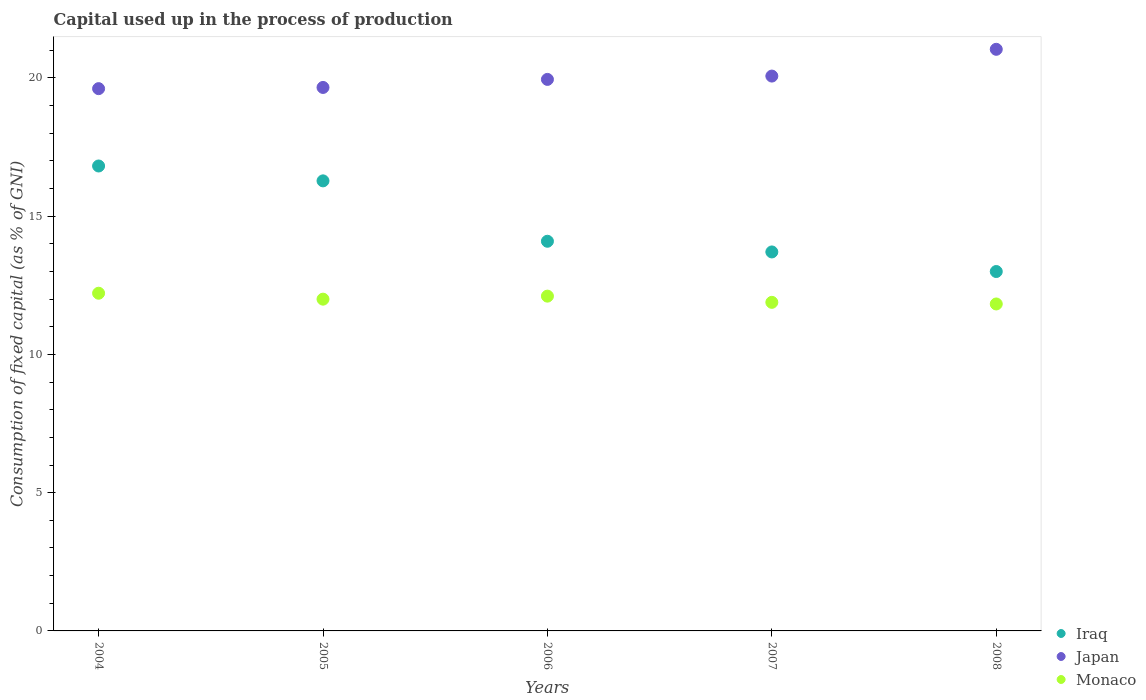How many different coloured dotlines are there?
Ensure brevity in your answer.  3. What is the capital used up in the process of production in Iraq in 2005?
Ensure brevity in your answer.  16.28. Across all years, what is the maximum capital used up in the process of production in Iraq?
Provide a short and direct response. 16.81. Across all years, what is the minimum capital used up in the process of production in Iraq?
Provide a short and direct response. 13. In which year was the capital used up in the process of production in Japan maximum?
Keep it short and to the point. 2008. In which year was the capital used up in the process of production in Iraq minimum?
Ensure brevity in your answer.  2008. What is the total capital used up in the process of production in Iraq in the graph?
Ensure brevity in your answer.  73.88. What is the difference between the capital used up in the process of production in Japan in 2007 and that in 2008?
Your answer should be compact. -0.97. What is the difference between the capital used up in the process of production in Iraq in 2005 and the capital used up in the process of production in Japan in 2007?
Your response must be concise. -3.79. What is the average capital used up in the process of production in Monaco per year?
Your answer should be very brief. 12. In the year 2007, what is the difference between the capital used up in the process of production in Iraq and capital used up in the process of production in Monaco?
Keep it short and to the point. 1.82. In how many years, is the capital used up in the process of production in Japan greater than 14 %?
Your answer should be very brief. 5. What is the ratio of the capital used up in the process of production in Monaco in 2006 to that in 2007?
Give a very brief answer. 1.02. Is the difference between the capital used up in the process of production in Iraq in 2006 and 2008 greater than the difference between the capital used up in the process of production in Monaco in 2006 and 2008?
Give a very brief answer. Yes. What is the difference between the highest and the second highest capital used up in the process of production in Japan?
Offer a terse response. 0.97. What is the difference between the highest and the lowest capital used up in the process of production in Japan?
Give a very brief answer. 1.42. Is the sum of the capital used up in the process of production in Iraq in 2006 and 2008 greater than the maximum capital used up in the process of production in Japan across all years?
Keep it short and to the point. Yes. Is it the case that in every year, the sum of the capital used up in the process of production in Monaco and capital used up in the process of production in Japan  is greater than the capital used up in the process of production in Iraq?
Provide a short and direct response. Yes. Is the capital used up in the process of production in Monaco strictly greater than the capital used up in the process of production in Iraq over the years?
Keep it short and to the point. No. Is the capital used up in the process of production in Iraq strictly less than the capital used up in the process of production in Japan over the years?
Give a very brief answer. Yes. How many dotlines are there?
Offer a very short reply. 3. How many years are there in the graph?
Keep it short and to the point. 5. Does the graph contain grids?
Provide a short and direct response. No. Where does the legend appear in the graph?
Offer a terse response. Bottom right. What is the title of the graph?
Provide a succinct answer. Capital used up in the process of production. Does "Luxembourg" appear as one of the legend labels in the graph?
Offer a terse response. No. What is the label or title of the X-axis?
Keep it short and to the point. Years. What is the label or title of the Y-axis?
Provide a succinct answer. Consumption of fixed capital (as % of GNI). What is the Consumption of fixed capital (as % of GNI) in Iraq in 2004?
Make the answer very short. 16.81. What is the Consumption of fixed capital (as % of GNI) in Japan in 2004?
Your answer should be very brief. 19.61. What is the Consumption of fixed capital (as % of GNI) in Monaco in 2004?
Your answer should be compact. 12.21. What is the Consumption of fixed capital (as % of GNI) of Iraq in 2005?
Ensure brevity in your answer.  16.28. What is the Consumption of fixed capital (as % of GNI) of Japan in 2005?
Ensure brevity in your answer.  19.65. What is the Consumption of fixed capital (as % of GNI) in Monaco in 2005?
Provide a succinct answer. 12. What is the Consumption of fixed capital (as % of GNI) in Iraq in 2006?
Provide a short and direct response. 14.09. What is the Consumption of fixed capital (as % of GNI) of Japan in 2006?
Keep it short and to the point. 19.95. What is the Consumption of fixed capital (as % of GNI) in Monaco in 2006?
Provide a short and direct response. 12.11. What is the Consumption of fixed capital (as % of GNI) in Iraq in 2007?
Keep it short and to the point. 13.71. What is the Consumption of fixed capital (as % of GNI) in Japan in 2007?
Keep it short and to the point. 20.07. What is the Consumption of fixed capital (as % of GNI) in Monaco in 2007?
Ensure brevity in your answer.  11.88. What is the Consumption of fixed capital (as % of GNI) of Iraq in 2008?
Your answer should be compact. 13. What is the Consumption of fixed capital (as % of GNI) of Japan in 2008?
Your answer should be compact. 21.03. What is the Consumption of fixed capital (as % of GNI) of Monaco in 2008?
Give a very brief answer. 11.82. Across all years, what is the maximum Consumption of fixed capital (as % of GNI) in Iraq?
Your answer should be very brief. 16.81. Across all years, what is the maximum Consumption of fixed capital (as % of GNI) of Japan?
Keep it short and to the point. 21.03. Across all years, what is the maximum Consumption of fixed capital (as % of GNI) of Monaco?
Offer a terse response. 12.21. Across all years, what is the minimum Consumption of fixed capital (as % of GNI) in Iraq?
Provide a succinct answer. 13. Across all years, what is the minimum Consumption of fixed capital (as % of GNI) in Japan?
Make the answer very short. 19.61. Across all years, what is the minimum Consumption of fixed capital (as % of GNI) in Monaco?
Keep it short and to the point. 11.82. What is the total Consumption of fixed capital (as % of GNI) in Iraq in the graph?
Your answer should be very brief. 73.88. What is the total Consumption of fixed capital (as % of GNI) in Japan in the graph?
Offer a very short reply. 100.31. What is the total Consumption of fixed capital (as % of GNI) of Monaco in the graph?
Your answer should be compact. 60.02. What is the difference between the Consumption of fixed capital (as % of GNI) in Iraq in 2004 and that in 2005?
Your answer should be compact. 0.54. What is the difference between the Consumption of fixed capital (as % of GNI) in Japan in 2004 and that in 2005?
Your answer should be very brief. -0.04. What is the difference between the Consumption of fixed capital (as % of GNI) of Monaco in 2004 and that in 2005?
Ensure brevity in your answer.  0.21. What is the difference between the Consumption of fixed capital (as % of GNI) in Iraq in 2004 and that in 2006?
Offer a very short reply. 2.72. What is the difference between the Consumption of fixed capital (as % of GNI) of Japan in 2004 and that in 2006?
Offer a very short reply. -0.33. What is the difference between the Consumption of fixed capital (as % of GNI) of Monaco in 2004 and that in 2006?
Make the answer very short. 0.11. What is the difference between the Consumption of fixed capital (as % of GNI) in Iraq in 2004 and that in 2007?
Your answer should be very brief. 3.11. What is the difference between the Consumption of fixed capital (as % of GNI) in Japan in 2004 and that in 2007?
Make the answer very short. -0.45. What is the difference between the Consumption of fixed capital (as % of GNI) in Monaco in 2004 and that in 2007?
Offer a terse response. 0.33. What is the difference between the Consumption of fixed capital (as % of GNI) in Iraq in 2004 and that in 2008?
Your answer should be compact. 3.82. What is the difference between the Consumption of fixed capital (as % of GNI) of Japan in 2004 and that in 2008?
Provide a succinct answer. -1.42. What is the difference between the Consumption of fixed capital (as % of GNI) of Monaco in 2004 and that in 2008?
Your answer should be compact. 0.39. What is the difference between the Consumption of fixed capital (as % of GNI) in Iraq in 2005 and that in 2006?
Ensure brevity in your answer.  2.18. What is the difference between the Consumption of fixed capital (as % of GNI) of Japan in 2005 and that in 2006?
Ensure brevity in your answer.  -0.29. What is the difference between the Consumption of fixed capital (as % of GNI) of Monaco in 2005 and that in 2006?
Your answer should be compact. -0.11. What is the difference between the Consumption of fixed capital (as % of GNI) of Iraq in 2005 and that in 2007?
Provide a short and direct response. 2.57. What is the difference between the Consumption of fixed capital (as % of GNI) of Japan in 2005 and that in 2007?
Your answer should be very brief. -0.41. What is the difference between the Consumption of fixed capital (as % of GNI) of Monaco in 2005 and that in 2007?
Your answer should be compact. 0.12. What is the difference between the Consumption of fixed capital (as % of GNI) of Iraq in 2005 and that in 2008?
Provide a short and direct response. 3.28. What is the difference between the Consumption of fixed capital (as % of GNI) in Japan in 2005 and that in 2008?
Provide a short and direct response. -1.38. What is the difference between the Consumption of fixed capital (as % of GNI) in Monaco in 2005 and that in 2008?
Keep it short and to the point. 0.17. What is the difference between the Consumption of fixed capital (as % of GNI) in Iraq in 2006 and that in 2007?
Make the answer very short. 0.39. What is the difference between the Consumption of fixed capital (as % of GNI) in Japan in 2006 and that in 2007?
Provide a short and direct response. -0.12. What is the difference between the Consumption of fixed capital (as % of GNI) in Monaco in 2006 and that in 2007?
Ensure brevity in your answer.  0.22. What is the difference between the Consumption of fixed capital (as % of GNI) of Iraq in 2006 and that in 2008?
Provide a succinct answer. 1.09. What is the difference between the Consumption of fixed capital (as % of GNI) of Japan in 2006 and that in 2008?
Offer a very short reply. -1.09. What is the difference between the Consumption of fixed capital (as % of GNI) of Monaco in 2006 and that in 2008?
Give a very brief answer. 0.28. What is the difference between the Consumption of fixed capital (as % of GNI) in Iraq in 2007 and that in 2008?
Your answer should be very brief. 0.71. What is the difference between the Consumption of fixed capital (as % of GNI) in Japan in 2007 and that in 2008?
Provide a short and direct response. -0.97. What is the difference between the Consumption of fixed capital (as % of GNI) of Monaco in 2007 and that in 2008?
Your answer should be very brief. 0.06. What is the difference between the Consumption of fixed capital (as % of GNI) of Iraq in 2004 and the Consumption of fixed capital (as % of GNI) of Japan in 2005?
Your answer should be very brief. -2.84. What is the difference between the Consumption of fixed capital (as % of GNI) in Iraq in 2004 and the Consumption of fixed capital (as % of GNI) in Monaco in 2005?
Your answer should be compact. 4.82. What is the difference between the Consumption of fixed capital (as % of GNI) of Japan in 2004 and the Consumption of fixed capital (as % of GNI) of Monaco in 2005?
Offer a very short reply. 7.61. What is the difference between the Consumption of fixed capital (as % of GNI) in Iraq in 2004 and the Consumption of fixed capital (as % of GNI) in Japan in 2006?
Offer a very short reply. -3.13. What is the difference between the Consumption of fixed capital (as % of GNI) of Iraq in 2004 and the Consumption of fixed capital (as % of GNI) of Monaco in 2006?
Ensure brevity in your answer.  4.71. What is the difference between the Consumption of fixed capital (as % of GNI) in Japan in 2004 and the Consumption of fixed capital (as % of GNI) in Monaco in 2006?
Keep it short and to the point. 7.5. What is the difference between the Consumption of fixed capital (as % of GNI) in Iraq in 2004 and the Consumption of fixed capital (as % of GNI) in Japan in 2007?
Give a very brief answer. -3.25. What is the difference between the Consumption of fixed capital (as % of GNI) of Iraq in 2004 and the Consumption of fixed capital (as % of GNI) of Monaco in 2007?
Your response must be concise. 4.93. What is the difference between the Consumption of fixed capital (as % of GNI) of Japan in 2004 and the Consumption of fixed capital (as % of GNI) of Monaco in 2007?
Your answer should be very brief. 7.73. What is the difference between the Consumption of fixed capital (as % of GNI) of Iraq in 2004 and the Consumption of fixed capital (as % of GNI) of Japan in 2008?
Provide a short and direct response. -4.22. What is the difference between the Consumption of fixed capital (as % of GNI) in Iraq in 2004 and the Consumption of fixed capital (as % of GNI) in Monaco in 2008?
Provide a short and direct response. 4.99. What is the difference between the Consumption of fixed capital (as % of GNI) in Japan in 2004 and the Consumption of fixed capital (as % of GNI) in Monaco in 2008?
Offer a terse response. 7.79. What is the difference between the Consumption of fixed capital (as % of GNI) in Iraq in 2005 and the Consumption of fixed capital (as % of GNI) in Japan in 2006?
Offer a very short reply. -3.67. What is the difference between the Consumption of fixed capital (as % of GNI) in Iraq in 2005 and the Consumption of fixed capital (as % of GNI) in Monaco in 2006?
Make the answer very short. 4.17. What is the difference between the Consumption of fixed capital (as % of GNI) of Japan in 2005 and the Consumption of fixed capital (as % of GNI) of Monaco in 2006?
Ensure brevity in your answer.  7.55. What is the difference between the Consumption of fixed capital (as % of GNI) of Iraq in 2005 and the Consumption of fixed capital (as % of GNI) of Japan in 2007?
Offer a terse response. -3.79. What is the difference between the Consumption of fixed capital (as % of GNI) of Iraq in 2005 and the Consumption of fixed capital (as % of GNI) of Monaco in 2007?
Ensure brevity in your answer.  4.39. What is the difference between the Consumption of fixed capital (as % of GNI) in Japan in 2005 and the Consumption of fixed capital (as % of GNI) in Monaco in 2007?
Provide a short and direct response. 7.77. What is the difference between the Consumption of fixed capital (as % of GNI) in Iraq in 2005 and the Consumption of fixed capital (as % of GNI) in Japan in 2008?
Give a very brief answer. -4.76. What is the difference between the Consumption of fixed capital (as % of GNI) in Iraq in 2005 and the Consumption of fixed capital (as % of GNI) in Monaco in 2008?
Keep it short and to the point. 4.45. What is the difference between the Consumption of fixed capital (as % of GNI) of Japan in 2005 and the Consumption of fixed capital (as % of GNI) of Monaco in 2008?
Provide a succinct answer. 7.83. What is the difference between the Consumption of fixed capital (as % of GNI) of Iraq in 2006 and the Consumption of fixed capital (as % of GNI) of Japan in 2007?
Your response must be concise. -5.97. What is the difference between the Consumption of fixed capital (as % of GNI) in Iraq in 2006 and the Consumption of fixed capital (as % of GNI) in Monaco in 2007?
Your answer should be compact. 2.21. What is the difference between the Consumption of fixed capital (as % of GNI) in Japan in 2006 and the Consumption of fixed capital (as % of GNI) in Monaco in 2007?
Offer a terse response. 8.06. What is the difference between the Consumption of fixed capital (as % of GNI) in Iraq in 2006 and the Consumption of fixed capital (as % of GNI) in Japan in 2008?
Your answer should be compact. -6.94. What is the difference between the Consumption of fixed capital (as % of GNI) of Iraq in 2006 and the Consumption of fixed capital (as % of GNI) of Monaco in 2008?
Provide a short and direct response. 2.27. What is the difference between the Consumption of fixed capital (as % of GNI) of Japan in 2006 and the Consumption of fixed capital (as % of GNI) of Monaco in 2008?
Offer a very short reply. 8.12. What is the difference between the Consumption of fixed capital (as % of GNI) of Iraq in 2007 and the Consumption of fixed capital (as % of GNI) of Japan in 2008?
Your answer should be compact. -7.33. What is the difference between the Consumption of fixed capital (as % of GNI) of Iraq in 2007 and the Consumption of fixed capital (as % of GNI) of Monaco in 2008?
Your answer should be compact. 1.88. What is the difference between the Consumption of fixed capital (as % of GNI) of Japan in 2007 and the Consumption of fixed capital (as % of GNI) of Monaco in 2008?
Ensure brevity in your answer.  8.24. What is the average Consumption of fixed capital (as % of GNI) of Iraq per year?
Give a very brief answer. 14.78. What is the average Consumption of fixed capital (as % of GNI) of Japan per year?
Your response must be concise. 20.06. What is the average Consumption of fixed capital (as % of GNI) of Monaco per year?
Keep it short and to the point. 12. In the year 2004, what is the difference between the Consumption of fixed capital (as % of GNI) of Iraq and Consumption of fixed capital (as % of GNI) of Japan?
Keep it short and to the point. -2.8. In the year 2004, what is the difference between the Consumption of fixed capital (as % of GNI) in Iraq and Consumption of fixed capital (as % of GNI) in Monaco?
Give a very brief answer. 4.6. In the year 2004, what is the difference between the Consumption of fixed capital (as % of GNI) of Japan and Consumption of fixed capital (as % of GNI) of Monaco?
Provide a short and direct response. 7.4. In the year 2005, what is the difference between the Consumption of fixed capital (as % of GNI) in Iraq and Consumption of fixed capital (as % of GNI) in Japan?
Offer a very short reply. -3.38. In the year 2005, what is the difference between the Consumption of fixed capital (as % of GNI) in Iraq and Consumption of fixed capital (as % of GNI) in Monaco?
Ensure brevity in your answer.  4.28. In the year 2005, what is the difference between the Consumption of fixed capital (as % of GNI) in Japan and Consumption of fixed capital (as % of GNI) in Monaco?
Offer a very short reply. 7.66. In the year 2006, what is the difference between the Consumption of fixed capital (as % of GNI) of Iraq and Consumption of fixed capital (as % of GNI) of Japan?
Give a very brief answer. -5.85. In the year 2006, what is the difference between the Consumption of fixed capital (as % of GNI) of Iraq and Consumption of fixed capital (as % of GNI) of Monaco?
Offer a very short reply. 1.98. In the year 2006, what is the difference between the Consumption of fixed capital (as % of GNI) in Japan and Consumption of fixed capital (as % of GNI) in Monaco?
Ensure brevity in your answer.  7.84. In the year 2007, what is the difference between the Consumption of fixed capital (as % of GNI) of Iraq and Consumption of fixed capital (as % of GNI) of Japan?
Keep it short and to the point. -6.36. In the year 2007, what is the difference between the Consumption of fixed capital (as % of GNI) of Iraq and Consumption of fixed capital (as % of GNI) of Monaco?
Provide a succinct answer. 1.82. In the year 2007, what is the difference between the Consumption of fixed capital (as % of GNI) in Japan and Consumption of fixed capital (as % of GNI) in Monaco?
Give a very brief answer. 8.18. In the year 2008, what is the difference between the Consumption of fixed capital (as % of GNI) in Iraq and Consumption of fixed capital (as % of GNI) in Japan?
Offer a very short reply. -8.04. In the year 2008, what is the difference between the Consumption of fixed capital (as % of GNI) in Iraq and Consumption of fixed capital (as % of GNI) in Monaco?
Your response must be concise. 1.17. In the year 2008, what is the difference between the Consumption of fixed capital (as % of GNI) in Japan and Consumption of fixed capital (as % of GNI) in Monaco?
Your answer should be very brief. 9.21. What is the ratio of the Consumption of fixed capital (as % of GNI) of Iraq in 2004 to that in 2005?
Your answer should be compact. 1.03. What is the ratio of the Consumption of fixed capital (as % of GNI) in Monaco in 2004 to that in 2005?
Your answer should be very brief. 1.02. What is the ratio of the Consumption of fixed capital (as % of GNI) of Iraq in 2004 to that in 2006?
Make the answer very short. 1.19. What is the ratio of the Consumption of fixed capital (as % of GNI) in Japan in 2004 to that in 2006?
Provide a succinct answer. 0.98. What is the ratio of the Consumption of fixed capital (as % of GNI) in Monaco in 2004 to that in 2006?
Give a very brief answer. 1.01. What is the ratio of the Consumption of fixed capital (as % of GNI) in Iraq in 2004 to that in 2007?
Offer a very short reply. 1.23. What is the ratio of the Consumption of fixed capital (as % of GNI) in Japan in 2004 to that in 2007?
Keep it short and to the point. 0.98. What is the ratio of the Consumption of fixed capital (as % of GNI) of Monaco in 2004 to that in 2007?
Your answer should be very brief. 1.03. What is the ratio of the Consumption of fixed capital (as % of GNI) of Iraq in 2004 to that in 2008?
Offer a very short reply. 1.29. What is the ratio of the Consumption of fixed capital (as % of GNI) of Japan in 2004 to that in 2008?
Keep it short and to the point. 0.93. What is the ratio of the Consumption of fixed capital (as % of GNI) of Monaco in 2004 to that in 2008?
Ensure brevity in your answer.  1.03. What is the ratio of the Consumption of fixed capital (as % of GNI) in Iraq in 2005 to that in 2006?
Offer a very short reply. 1.16. What is the ratio of the Consumption of fixed capital (as % of GNI) of Japan in 2005 to that in 2006?
Your answer should be very brief. 0.99. What is the ratio of the Consumption of fixed capital (as % of GNI) of Monaco in 2005 to that in 2006?
Offer a terse response. 0.99. What is the ratio of the Consumption of fixed capital (as % of GNI) of Iraq in 2005 to that in 2007?
Offer a very short reply. 1.19. What is the ratio of the Consumption of fixed capital (as % of GNI) in Japan in 2005 to that in 2007?
Keep it short and to the point. 0.98. What is the ratio of the Consumption of fixed capital (as % of GNI) in Monaco in 2005 to that in 2007?
Offer a very short reply. 1.01. What is the ratio of the Consumption of fixed capital (as % of GNI) of Iraq in 2005 to that in 2008?
Keep it short and to the point. 1.25. What is the ratio of the Consumption of fixed capital (as % of GNI) in Japan in 2005 to that in 2008?
Your answer should be very brief. 0.93. What is the ratio of the Consumption of fixed capital (as % of GNI) of Monaco in 2005 to that in 2008?
Your answer should be compact. 1.01. What is the ratio of the Consumption of fixed capital (as % of GNI) in Iraq in 2006 to that in 2007?
Your answer should be compact. 1.03. What is the ratio of the Consumption of fixed capital (as % of GNI) of Japan in 2006 to that in 2007?
Keep it short and to the point. 0.99. What is the ratio of the Consumption of fixed capital (as % of GNI) in Monaco in 2006 to that in 2007?
Your response must be concise. 1.02. What is the ratio of the Consumption of fixed capital (as % of GNI) of Iraq in 2006 to that in 2008?
Provide a succinct answer. 1.08. What is the ratio of the Consumption of fixed capital (as % of GNI) of Japan in 2006 to that in 2008?
Give a very brief answer. 0.95. What is the ratio of the Consumption of fixed capital (as % of GNI) of Iraq in 2007 to that in 2008?
Your answer should be very brief. 1.05. What is the ratio of the Consumption of fixed capital (as % of GNI) in Japan in 2007 to that in 2008?
Offer a very short reply. 0.95. What is the ratio of the Consumption of fixed capital (as % of GNI) in Monaco in 2007 to that in 2008?
Offer a terse response. 1. What is the difference between the highest and the second highest Consumption of fixed capital (as % of GNI) in Iraq?
Keep it short and to the point. 0.54. What is the difference between the highest and the second highest Consumption of fixed capital (as % of GNI) of Japan?
Your answer should be compact. 0.97. What is the difference between the highest and the second highest Consumption of fixed capital (as % of GNI) in Monaco?
Your response must be concise. 0.11. What is the difference between the highest and the lowest Consumption of fixed capital (as % of GNI) of Iraq?
Make the answer very short. 3.82. What is the difference between the highest and the lowest Consumption of fixed capital (as % of GNI) of Japan?
Give a very brief answer. 1.42. What is the difference between the highest and the lowest Consumption of fixed capital (as % of GNI) in Monaco?
Your answer should be compact. 0.39. 